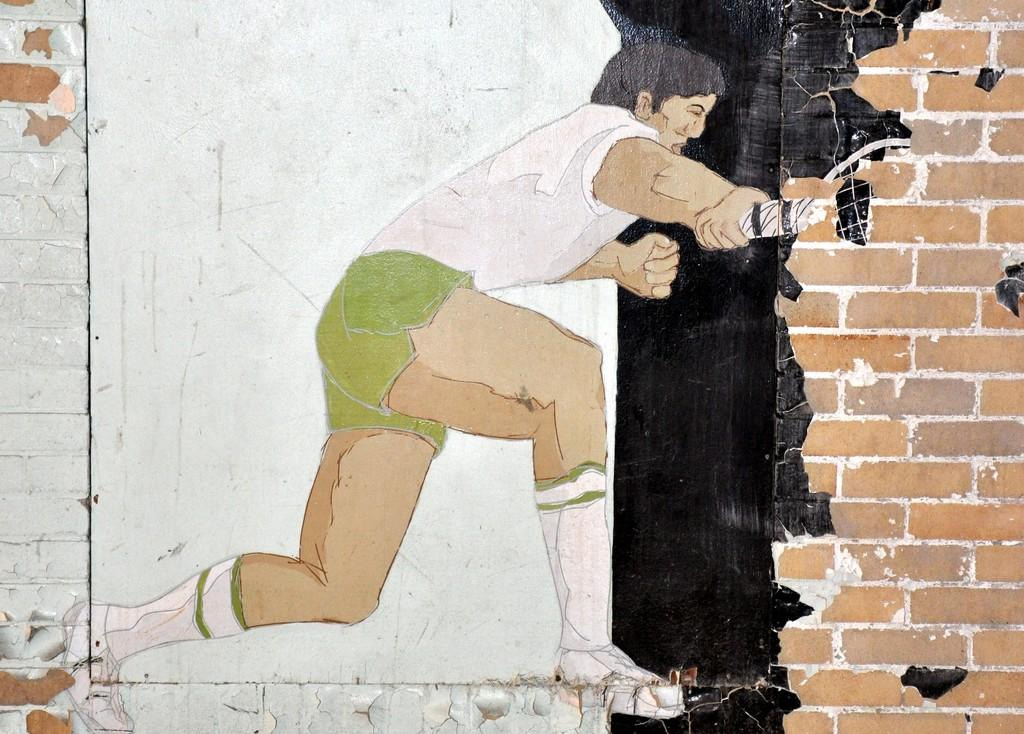What is depicted in the image? There is a painting in the image. What is the subject of the painting? The painting is of a boy. What is the boy doing in the painting? The boy is holding an object in the painting. Where is the painting located? The painting is on a wall. Can you see any bubbles in the painting? There are no bubbles present in the painting; it features a boy holding an object. 